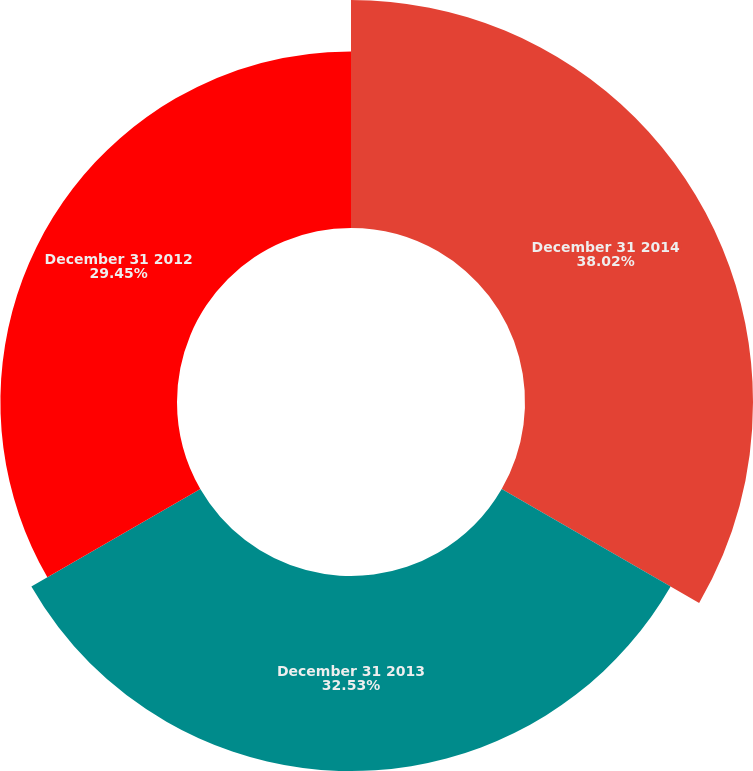<chart> <loc_0><loc_0><loc_500><loc_500><pie_chart><fcel>December 31 2014<fcel>December 31 2013<fcel>December 31 2012<nl><fcel>38.02%<fcel>32.53%<fcel>29.45%<nl></chart> 